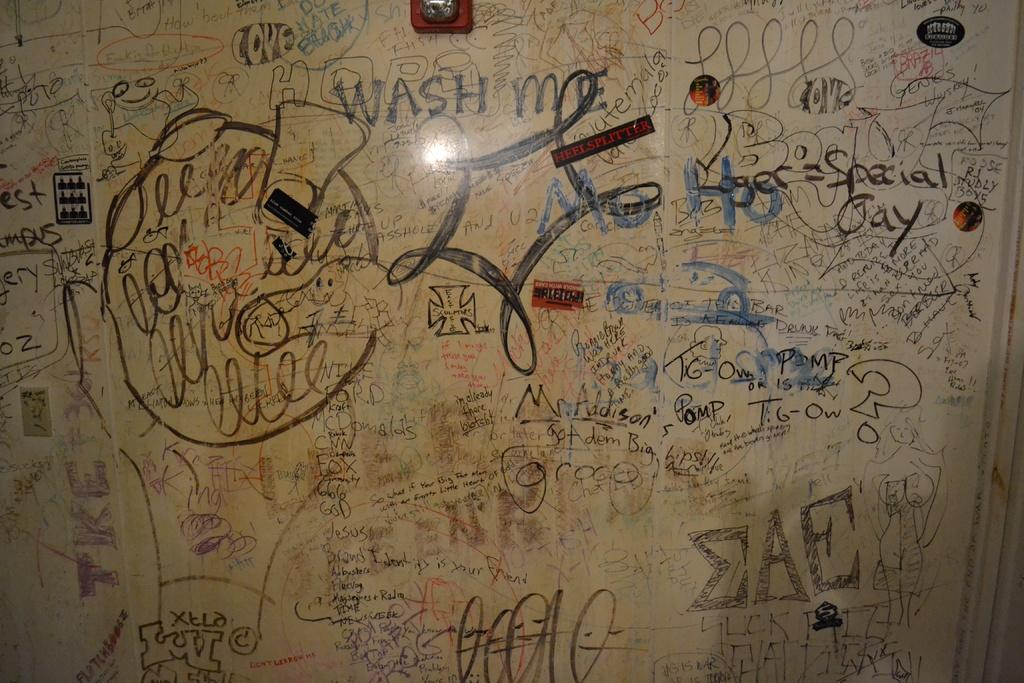<image>
Give a short and clear explanation of the subsequent image. Many pieces of graffiti on a wall with the words Wash Me 